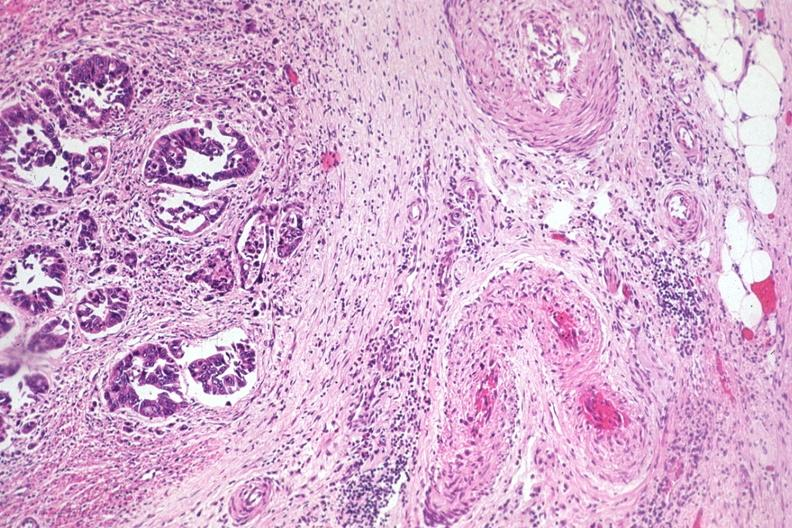where is this from?
Answer the question using a single word or phrase. Gastrointestinal system 